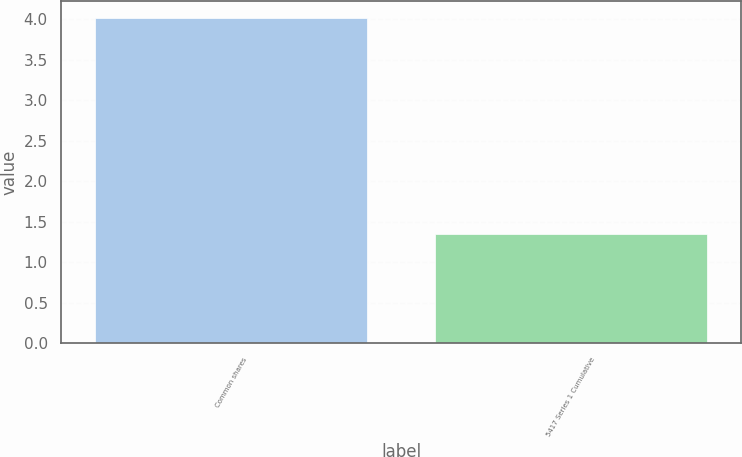<chart> <loc_0><loc_0><loc_500><loc_500><bar_chart><fcel>Common shares<fcel>5417 Series 1 Cumulative<nl><fcel>4.02<fcel>1.35<nl></chart> 